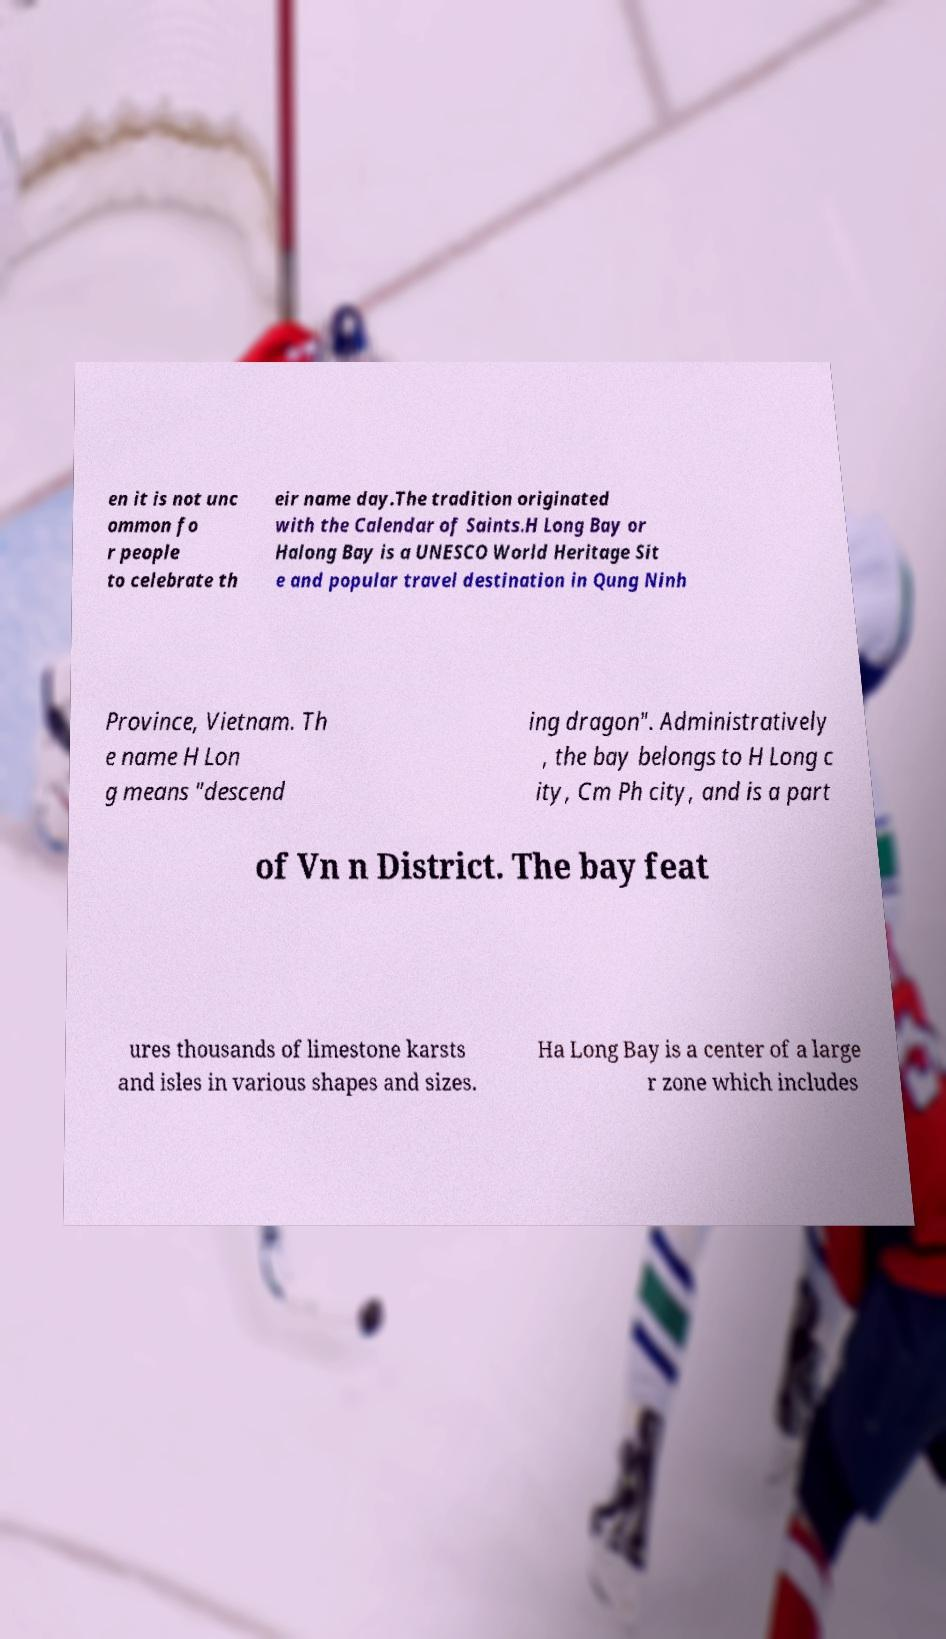Could you assist in decoding the text presented in this image and type it out clearly? en it is not unc ommon fo r people to celebrate th eir name day.The tradition originated with the Calendar of Saints.H Long Bay or Halong Bay is a UNESCO World Heritage Sit e and popular travel destination in Qung Ninh Province, Vietnam. Th e name H Lon g means "descend ing dragon". Administratively , the bay belongs to H Long c ity, Cm Ph city, and is a part of Vn n District. The bay feat ures thousands of limestone karsts and isles in various shapes and sizes. Ha Long Bay is a center of a large r zone which includes 